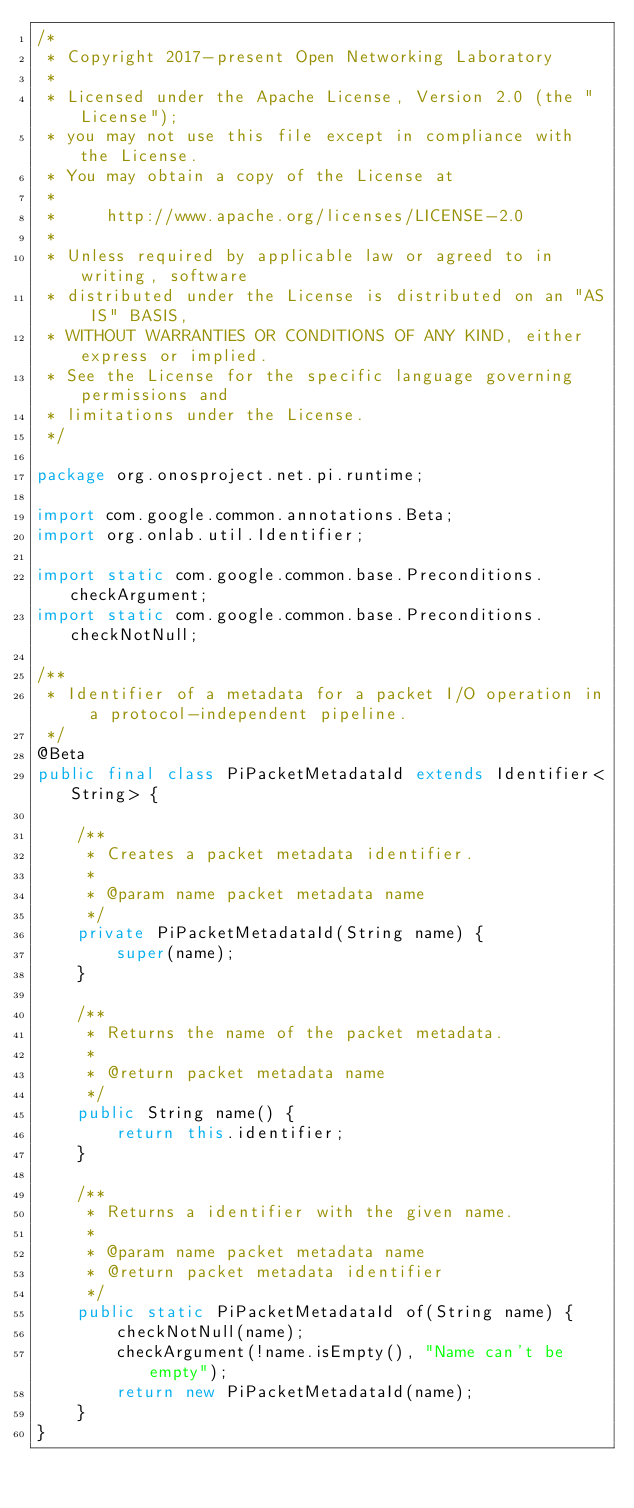Convert code to text. <code><loc_0><loc_0><loc_500><loc_500><_Java_>/*
 * Copyright 2017-present Open Networking Laboratory
 *
 * Licensed under the Apache License, Version 2.0 (the "License");
 * you may not use this file except in compliance with the License.
 * You may obtain a copy of the License at
 *
 *     http://www.apache.org/licenses/LICENSE-2.0
 *
 * Unless required by applicable law or agreed to in writing, software
 * distributed under the License is distributed on an "AS IS" BASIS,
 * WITHOUT WARRANTIES OR CONDITIONS OF ANY KIND, either express or implied.
 * See the License for the specific language governing permissions and
 * limitations under the License.
 */

package org.onosproject.net.pi.runtime;

import com.google.common.annotations.Beta;
import org.onlab.util.Identifier;

import static com.google.common.base.Preconditions.checkArgument;
import static com.google.common.base.Preconditions.checkNotNull;

/**
 * Identifier of a metadata for a packet I/O operation in a protocol-independent pipeline.
 */
@Beta
public final class PiPacketMetadataId extends Identifier<String> {

    /**
     * Creates a packet metadata identifier.
     *
     * @param name packet metadata name
     */
    private PiPacketMetadataId(String name) {
        super(name);
    }

    /**
     * Returns the name of the packet metadata.
     *
     * @return packet metadata name
     */
    public String name() {
        return this.identifier;
    }

    /**
     * Returns a identifier with the given name.
     *
     * @param name packet metadata name
     * @return packet metadata identifier
     */
    public static PiPacketMetadataId of(String name) {
        checkNotNull(name);
        checkArgument(!name.isEmpty(), "Name can't be empty");
        return new PiPacketMetadataId(name);
    }
}
</code> 